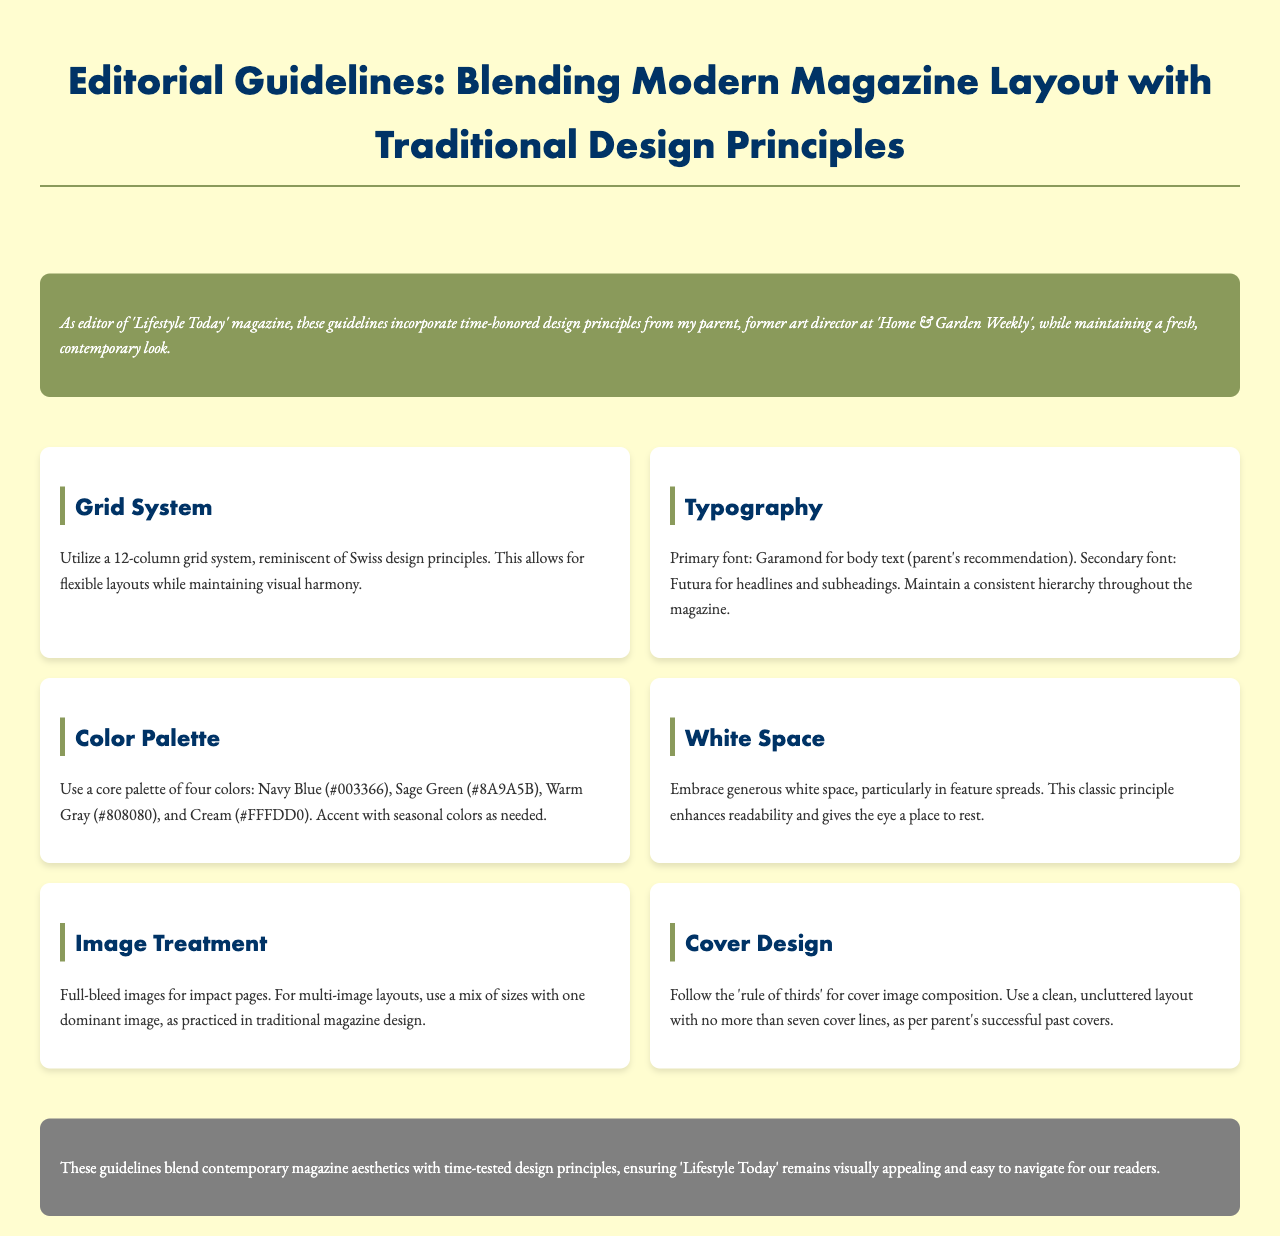What is the primary font recommended for body text? The document states that the primary font for body text is Garamond, which was specifically recommended by the editor's parent.
Answer: Garamond What grid system should be utilized for layout? The guidelines recommend using a 12-column grid system.
Answer: 12-column grid What colors are included in the core palette? The document lists the core palette colors as Navy Blue, Sage Green, Warm Gray, and Cream.
Answer: Navy Blue, Sage Green, Warm Gray, Cream What design principle enhances readability? The document emphasizes embracing generous white space as a design principle to enhance readability.
Answer: Generous white space What is recommended for cover image composition? The document specifies following the 'rule of thirds' for cover image composition.
Answer: Rule of thirds What should the maximum number of cover lines be? The policy recommends no more than seven cover lines on the magazine cover.
Answer: Seven What design style does the document primarily combine? The editorial guidelines primarily combine modern magazine aesthetics with traditional design principles.
Answer: Modern and traditional design principles What type of images are suggested for impact pages? The document suggests using full-bleed images for impact pages.
Answer: Full-bleed images What is the significance of seasonal colors? The document mentions that seasonal colors can be used to accent the core color palette as needed.
Answer: Accent with seasonal colors 